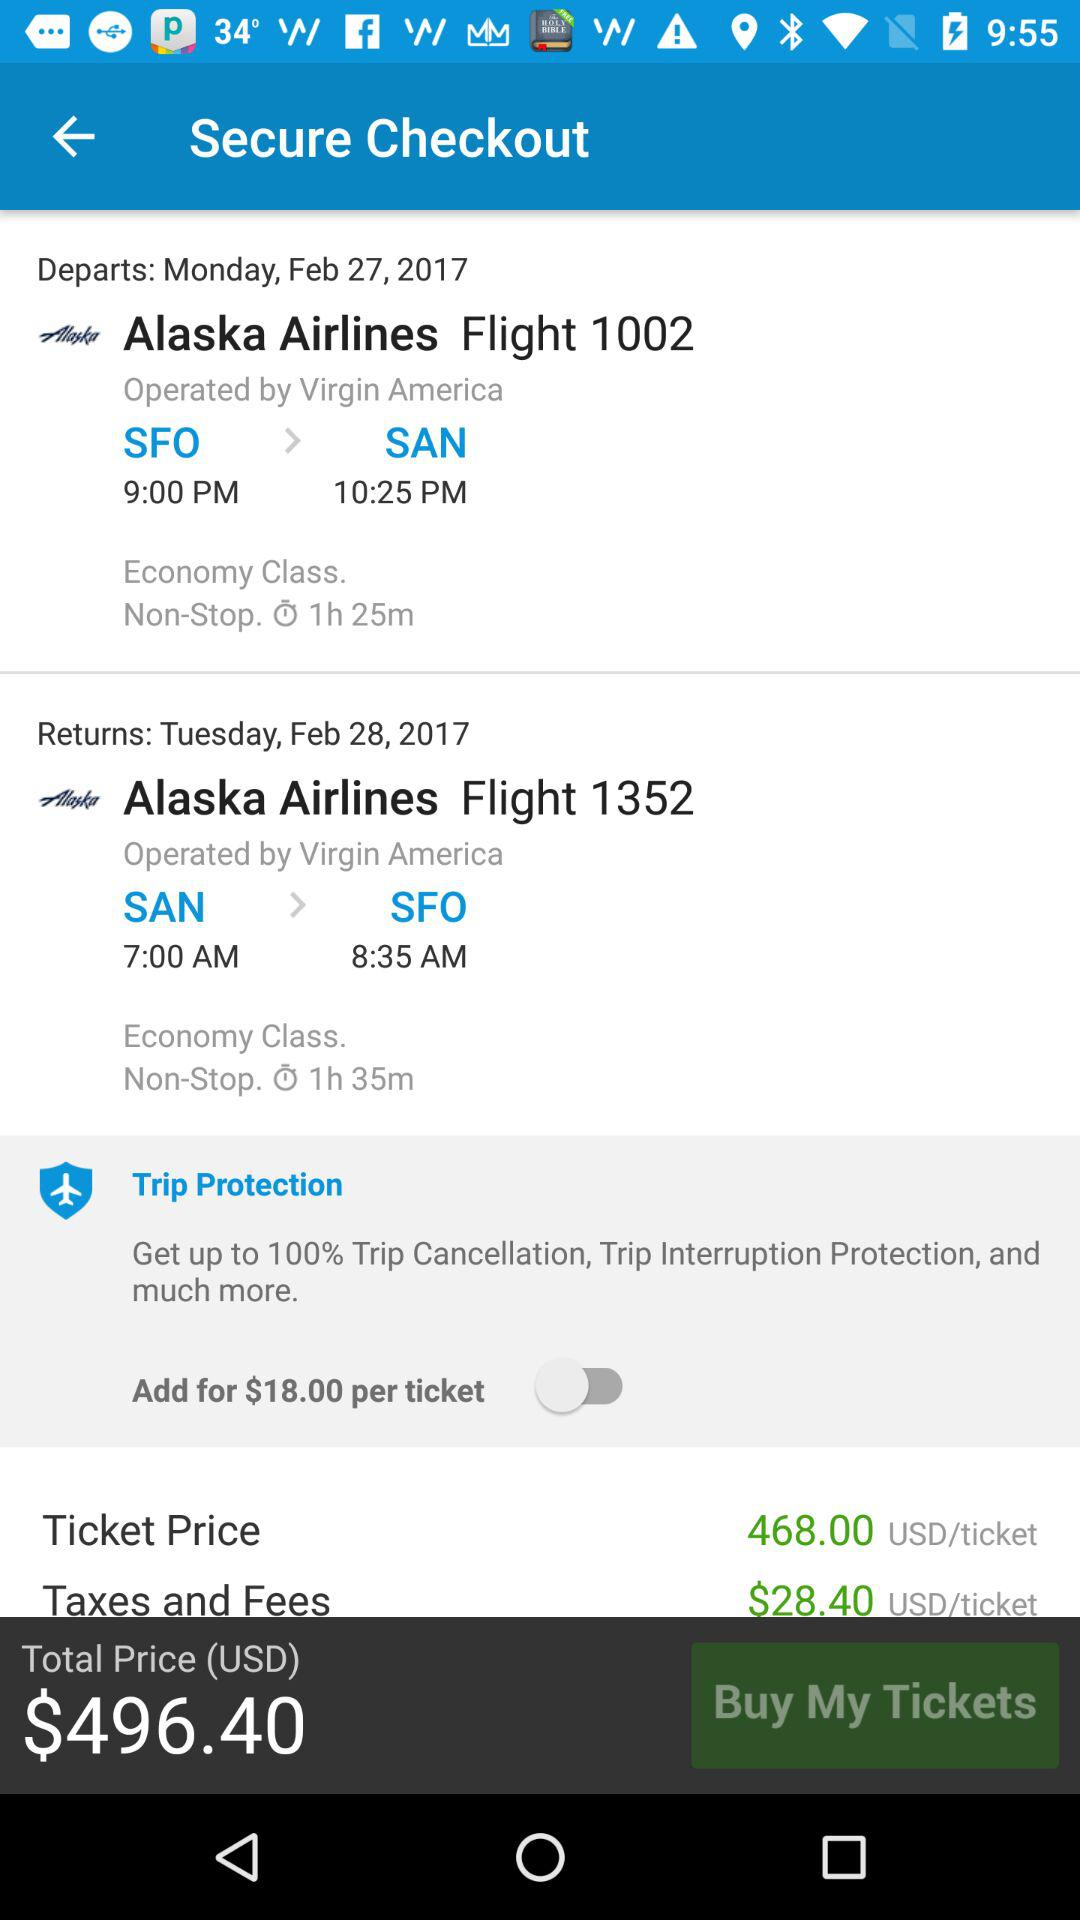What is the total price?
Answer the question using a single word or phrase. The total price is $496.40 